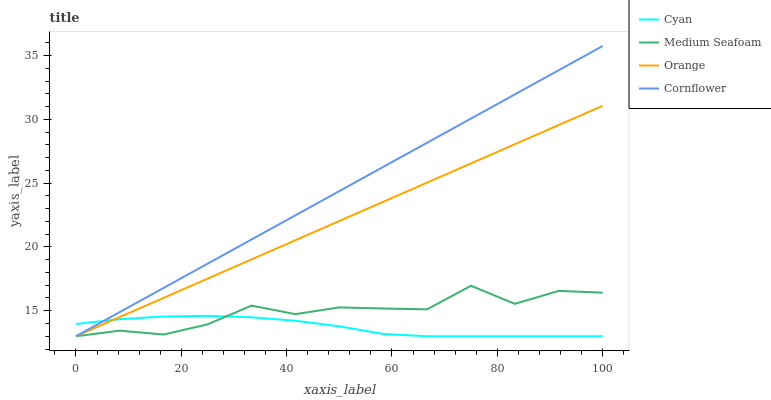Does Cyan have the minimum area under the curve?
Answer yes or no. Yes. Does Cornflower have the maximum area under the curve?
Answer yes or no. Yes. Does Medium Seafoam have the minimum area under the curve?
Answer yes or no. No. Does Medium Seafoam have the maximum area under the curve?
Answer yes or no. No. Is Orange the smoothest?
Answer yes or no. Yes. Is Medium Seafoam the roughest?
Answer yes or no. Yes. Is Cyan the smoothest?
Answer yes or no. No. Is Cyan the roughest?
Answer yes or no. No. Does Orange have the lowest value?
Answer yes or no. Yes. Does Cornflower have the highest value?
Answer yes or no. Yes. Does Medium Seafoam have the highest value?
Answer yes or no. No. Does Orange intersect Cyan?
Answer yes or no. Yes. Is Orange less than Cyan?
Answer yes or no. No. Is Orange greater than Cyan?
Answer yes or no. No. 